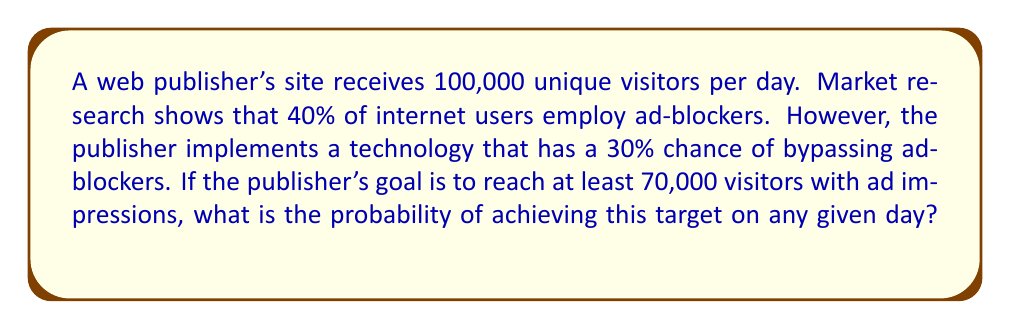Can you solve this math problem? Let's approach this step-by-step:

1) First, let's calculate the expected number of visitors without ad-blockers:
   $100,000 \times (1 - 0.40) = 60,000$ visitors

2) For the visitors with ad-blockers (40,000), we have a 30% chance of bypassing:
   $40,000 \times 0.30 = 12,000$ additional visitors (expected)

3) So, on average, we expect to reach:
   $60,000 + 12,000 = 72,000$ visitors

4) However, the actual number will vary day to day. We can model this as a binomial distribution with $n = 100,000$ trials (visitors) and $p = 0.72$ probability of success (reaching a visitor).

5) We want the probability of reaching at least 70,000 visitors. In binomial distribution notation, this is:

   $$P(X \geq 70000) = 1 - P(X < 70000)$$

6) We can use the normal approximation to the binomial distribution since $n$ is large and $np$ and $n(1-p)$ are both greater than 5.

7) The mean of this normal approximation is $\mu = np = 100,000 \times 0.72 = 72,000$

8) The standard deviation is $\sigma = \sqrt{np(1-p)} = \sqrt{100,000 \times 0.72 \times 0.28} = 449.72$

9) We can now calculate the z-score for 69,999.5 (using continuity correction):

   $$z = \frac{69999.5 - 72000}{449.72} = -4.45$$

10) Using a standard normal table or calculator, we find:
    $P(Z < -4.45) \approx 0.0000043$

11) Therefore, $P(X \geq 70000) = 1 - 0.0000043 = 0.9999957$
Answer: The probability of reaching at least 70,000 visitors with ad impressions on any given day is approximately 0.9999957 or 99.99957%. 